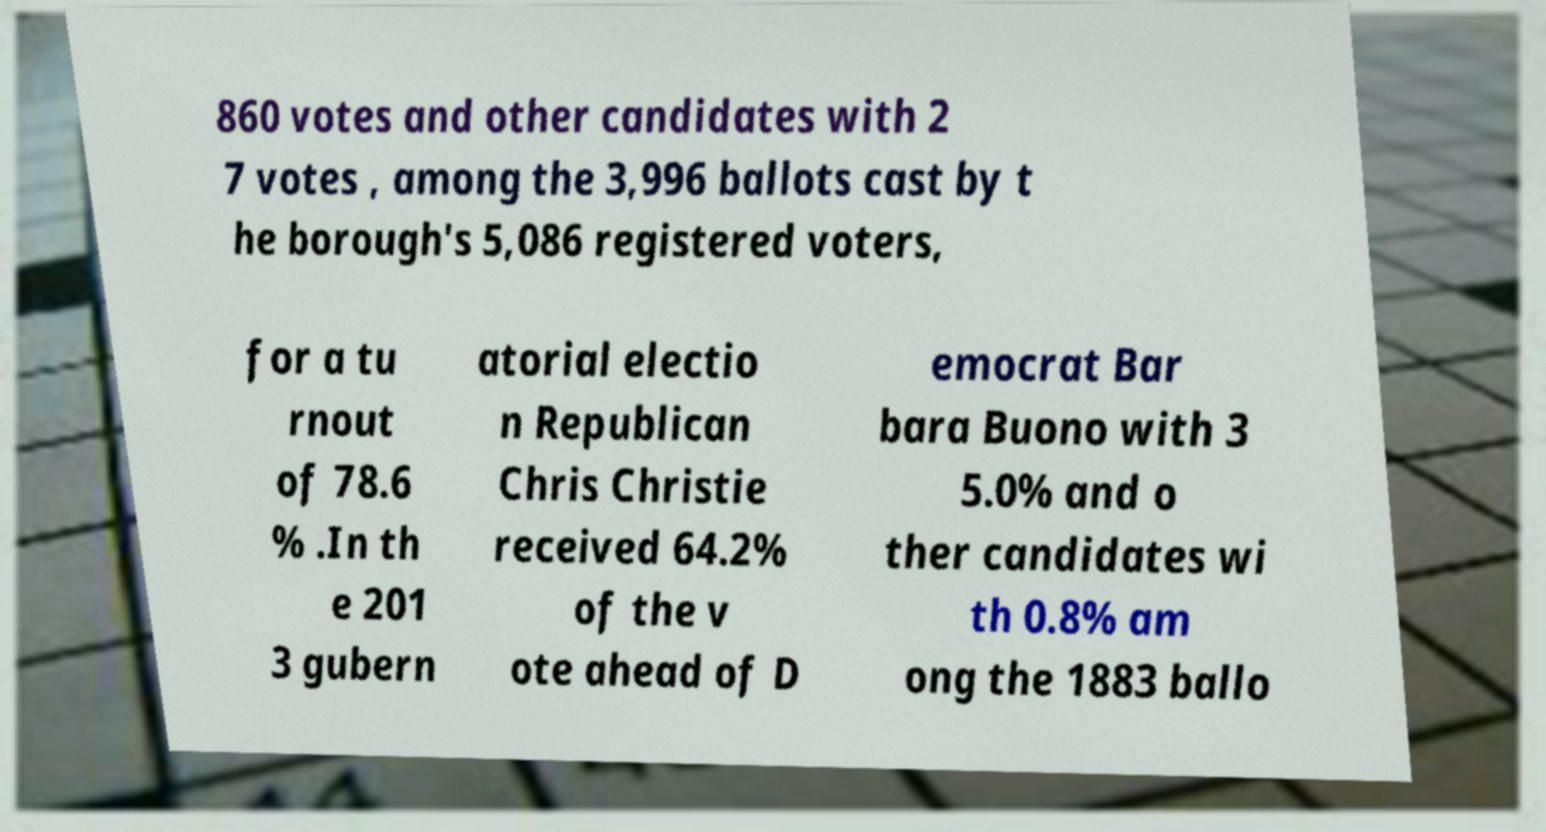Please read and relay the text visible in this image. What does it say? 860 votes and other candidates with 2 7 votes , among the 3,996 ballots cast by t he borough's 5,086 registered voters, for a tu rnout of 78.6 % .In th e 201 3 gubern atorial electio n Republican Chris Christie received 64.2% of the v ote ahead of D emocrat Bar bara Buono with 3 5.0% and o ther candidates wi th 0.8% am ong the 1883 ballo 